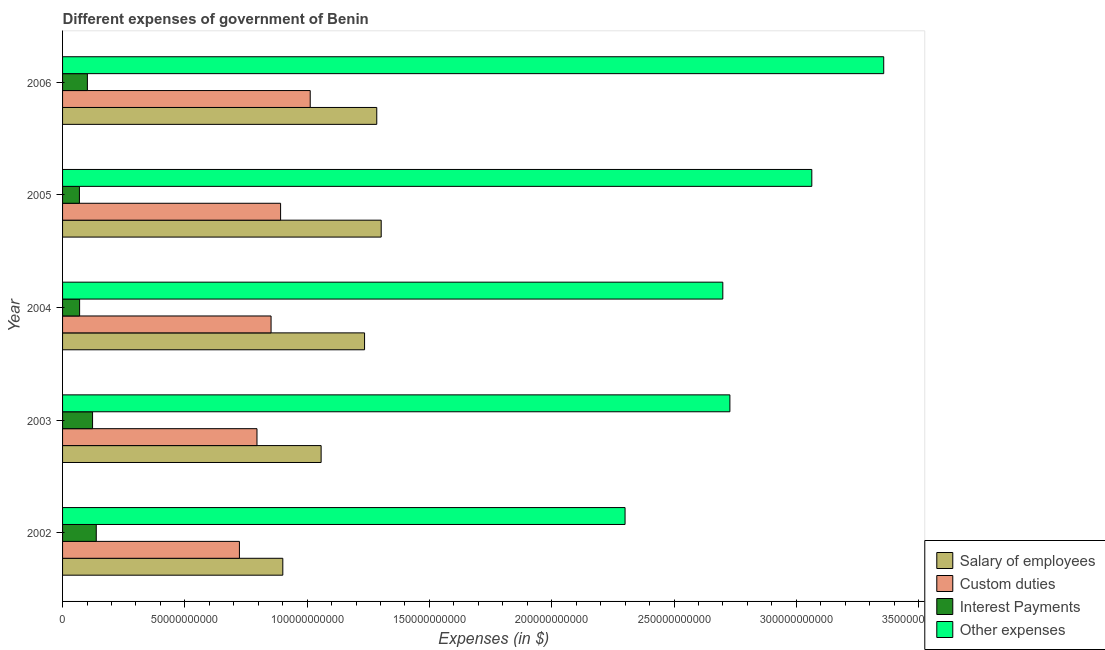How many groups of bars are there?
Offer a very short reply. 5. How many bars are there on the 5th tick from the top?
Your answer should be compact. 4. What is the label of the 4th group of bars from the top?
Give a very brief answer. 2003. What is the amount spent on other expenses in 2002?
Your response must be concise. 2.30e+11. Across all years, what is the maximum amount spent on custom duties?
Your response must be concise. 1.01e+11. Across all years, what is the minimum amount spent on interest payments?
Your answer should be very brief. 6.89e+09. In which year was the amount spent on salary of employees maximum?
Keep it short and to the point. 2005. In which year was the amount spent on custom duties minimum?
Keep it short and to the point. 2002. What is the total amount spent on salary of employees in the graph?
Ensure brevity in your answer.  5.78e+11. What is the difference between the amount spent on other expenses in 2002 and that in 2006?
Your answer should be compact. -1.06e+11. What is the difference between the amount spent on custom duties in 2006 and the amount spent on other expenses in 2002?
Your answer should be very brief. -1.29e+11. What is the average amount spent on salary of employees per year?
Your answer should be very brief. 1.16e+11. In the year 2004, what is the difference between the amount spent on custom duties and amount spent on interest payments?
Provide a short and direct response. 7.83e+1. Is the amount spent on interest payments in 2003 less than that in 2006?
Offer a terse response. No. Is the difference between the amount spent on interest payments in 2002 and 2004 greater than the difference between the amount spent on other expenses in 2002 and 2004?
Provide a short and direct response. Yes. What is the difference between the highest and the second highest amount spent on interest payments?
Make the answer very short. 1.51e+09. What is the difference between the highest and the lowest amount spent on salary of employees?
Your response must be concise. 4.02e+1. In how many years, is the amount spent on interest payments greater than the average amount spent on interest payments taken over all years?
Provide a succinct answer. 3. Is it the case that in every year, the sum of the amount spent on other expenses and amount spent on salary of employees is greater than the sum of amount spent on interest payments and amount spent on custom duties?
Give a very brief answer. No. What does the 1st bar from the top in 2003 represents?
Offer a very short reply. Other expenses. What does the 2nd bar from the bottom in 2006 represents?
Keep it short and to the point. Custom duties. Is it the case that in every year, the sum of the amount spent on salary of employees and amount spent on custom duties is greater than the amount spent on interest payments?
Your answer should be very brief. Yes. How many bars are there?
Your answer should be compact. 20. How many years are there in the graph?
Ensure brevity in your answer.  5. Are the values on the major ticks of X-axis written in scientific E-notation?
Your answer should be compact. No. Does the graph contain any zero values?
Make the answer very short. No. Does the graph contain grids?
Provide a short and direct response. No. What is the title of the graph?
Make the answer very short. Different expenses of government of Benin. Does "Luxembourg" appear as one of the legend labels in the graph?
Your answer should be very brief. No. What is the label or title of the X-axis?
Ensure brevity in your answer.  Expenses (in $). What is the label or title of the Y-axis?
Make the answer very short. Year. What is the Expenses (in $) in Salary of employees in 2002?
Your response must be concise. 9.00e+1. What is the Expenses (in $) in Custom duties in 2002?
Make the answer very short. 7.23e+1. What is the Expenses (in $) in Interest Payments in 2002?
Your answer should be compact. 1.38e+1. What is the Expenses (in $) in Other expenses in 2002?
Provide a succinct answer. 2.30e+11. What is the Expenses (in $) in Salary of employees in 2003?
Provide a succinct answer. 1.06e+11. What is the Expenses (in $) in Custom duties in 2003?
Your answer should be compact. 7.95e+1. What is the Expenses (in $) of Interest Payments in 2003?
Ensure brevity in your answer.  1.23e+1. What is the Expenses (in $) in Other expenses in 2003?
Make the answer very short. 2.73e+11. What is the Expenses (in $) in Salary of employees in 2004?
Offer a very short reply. 1.23e+11. What is the Expenses (in $) of Custom duties in 2004?
Keep it short and to the point. 8.52e+1. What is the Expenses (in $) in Interest Payments in 2004?
Provide a succinct answer. 6.97e+09. What is the Expenses (in $) in Other expenses in 2004?
Give a very brief answer. 2.70e+11. What is the Expenses (in $) of Salary of employees in 2005?
Your answer should be compact. 1.30e+11. What is the Expenses (in $) in Custom duties in 2005?
Make the answer very short. 8.91e+1. What is the Expenses (in $) of Interest Payments in 2005?
Offer a terse response. 6.89e+09. What is the Expenses (in $) of Other expenses in 2005?
Your answer should be very brief. 3.06e+11. What is the Expenses (in $) of Salary of employees in 2006?
Provide a short and direct response. 1.28e+11. What is the Expenses (in $) of Custom duties in 2006?
Offer a terse response. 1.01e+11. What is the Expenses (in $) in Interest Payments in 2006?
Offer a very short reply. 1.01e+1. What is the Expenses (in $) in Other expenses in 2006?
Your answer should be compact. 3.36e+11. Across all years, what is the maximum Expenses (in $) of Salary of employees?
Provide a succinct answer. 1.30e+11. Across all years, what is the maximum Expenses (in $) of Custom duties?
Offer a terse response. 1.01e+11. Across all years, what is the maximum Expenses (in $) in Interest Payments?
Make the answer very short. 1.38e+1. Across all years, what is the maximum Expenses (in $) of Other expenses?
Offer a very short reply. 3.36e+11. Across all years, what is the minimum Expenses (in $) of Salary of employees?
Offer a very short reply. 9.00e+1. Across all years, what is the minimum Expenses (in $) of Custom duties?
Give a very brief answer. 7.23e+1. Across all years, what is the minimum Expenses (in $) in Interest Payments?
Your answer should be very brief. 6.89e+09. Across all years, what is the minimum Expenses (in $) of Other expenses?
Provide a short and direct response. 2.30e+11. What is the total Expenses (in $) in Salary of employees in the graph?
Offer a very short reply. 5.78e+11. What is the total Expenses (in $) in Custom duties in the graph?
Make the answer very short. 4.27e+11. What is the total Expenses (in $) of Interest Payments in the graph?
Provide a short and direct response. 5.01e+1. What is the total Expenses (in $) of Other expenses in the graph?
Make the answer very short. 1.41e+12. What is the difference between the Expenses (in $) in Salary of employees in 2002 and that in 2003?
Make the answer very short. -1.57e+1. What is the difference between the Expenses (in $) of Custom duties in 2002 and that in 2003?
Offer a very short reply. -7.18e+09. What is the difference between the Expenses (in $) of Interest Payments in 2002 and that in 2003?
Provide a short and direct response. 1.51e+09. What is the difference between the Expenses (in $) in Other expenses in 2002 and that in 2003?
Offer a very short reply. -4.29e+1. What is the difference between the Expenses (in $) of Salary of employees in 2002 and that in 2004?
Offer a very short reply. -3.34e+1. What is the difference between the Expenses (in $) in Custom duties in 2002 and that in 2004?
Provide a succinct answer. -1.29e+1. What is the difference between the Expenses (in $) of Interest Payments in 2002 and that in 2004?
Offer a very short reply. 6.81e+09. What is the difference between the Expenses (in $) of Other expenses in 2002 and that in 2004?
Offer a very short reply. -4.00e+1. What is the difference between the Expenses (in $) of Salary of employees in 2002 and that in 2005?
Ensure brevity in your answer.  -4.02e+1. What is the difference between the Expenses (in $) of Custom duties in 2002 and that in 2005?
Give a very brief answer. -1.68e+1. What is the difference between the Expenses (in $) in Interest Payments in 2002 and that in 2005?
Offer a terse response. 6.89e+09. What is the difference between the Expenses (in $) in Other expenses in 2002 and that in 2005?
Provide a short and direct response. -7.64e+1. What is the difference between the Expenses (in $) in Salary of employees in 2002 and that in 2006?
Keep it short and to the point. -3.84e+1. What is the difference between the Expenses (in $) in Custom duties in 2002 and that in 2006?
Ensure brevity in your answer.  -2.89e+1. What is the difference between the Expenses (in $) of Interest Payments in 2002 and that in 2006?
Keep it short and to the point. 3.63e+09. What is the difference between the Expenses (in $) in Other expenses in 2002 and that in 2006?
Provide a succinct answer. -1.06e+11. What is the difference between the Expenses (in $) of Salary of employees in 2003 and that in 2004?
Your answer should be compact. -1.78e+1. What is the difference between the Expenses (in $) in Custom duties in 2003 and that in 2004?
Ensure brevity in your answer.  -5.75e+09. What is the difference between the Expenses (in $) in Interest Payments in 2003 and that in 2004?
Make the answer very short. 5.30e+09. What is the difference between the Expenses (in $) of Other expenses in 2003 and that in 2004?
Your answer should be compact. 2.89e+09. What is the difference between the Expenses (in $) of Salary of employees in 2003 and that in 2005?
Provide a succinct answer. -2.46e+1. What is the difference between the Expenses (in $) in Custom duties in 2003 and that in 2005?
Offer a terse response. -9.65e+09. What is the difference between the Expenses (in $) of Interest Payments in 2003 and that in 2005?
Keep it short and to the point. 5.38e+09. What is the difference between the Expenses (in $) in Other expenses in 2003 and that in 2005?
Provide a short and direct response. -3.35e+1. What is the difference between the Expenses (in $) in Salary of employees in 2003 and that in 2006?
Your response must be concise. -2.27e+1. What is the difference between the Expenses (in $) of Custom duties in 2003 and that in 2006?
Offer a terse response. -2.18e+1. What is the difference between the Expenses (in $) in Interest Payments in 2003 and that in 2006?
Offer a terse response. 2.12e+09. What is the difference between the Expenses (in $) in Other expenses in 2003 and that in 2006?
Your answer should be compact. -6.29e+1. What is the difference between the Expenses (in $) in Salary of employees in 2004 and that in 2005?
Your answer should be compact. -6.80e+09. What is the difference between the Expenses (in $) in Custom duties in 2004 and that in 2005?
Keep it short and to the point. -3.90e+09. What is the difference between the Expenses (in $) in Interest Payments in 2004 and that in 2005?
Provide a short and direct response. 8.00e+07. What is the difference between the Expenses (in $) of Other expenses in 2004 and that in 2005?
Your answer should be very brief. -3.64e+1. What is the difference between the Expenses (in $) in Salary of employees in 2004 and that in 2006?
Make the answer very short. -4.99e+09. What is the difference between the Expenses (in $) in Custom duties in 2004 and that in 2006?
Your response must be concise. -1.60e+1. What is the difference between the Expenses (in $) in Interest Payments in 2004 and that in 2006?
Offer a very short reply. -3.18e+09. What is the difference between the Expenses (in $) in Other expenses in 2004 and that in 2006?
Your response must be concise. -6.58e+1. What is the difference between the Expenses (in $) of Salary of employees in 2005 and that in 2006?
Provide a succinct answer. 1.81e+09. What is the difference between the Expenses (in $) in Custom duties in 2005 and that in 2006?
Ensure brevity in your answer.  -1.21e+1. What is the difference between the Expenses (in $) in Interest Payments in 2005 and that in 2006?
Offer a very short reply. -3.26e+09. What is the difference between the Expenses (in $) of Other expenses in 2005 and that in 2006?
Offer a terse response. -2.94e+1. What is the difference between the Expenses (in $) in Salary of employees in 2002 and the Expenses (in $) in Custom duties in 2003?
Offer a terse response. 1.06e+1. What is the difference between the Expenses (in $) of Salary of employees in 2002 and the Expenses (in $) of Interest Payments in 2003?
Give a very brief answer. 7.78e+1. What is the difference between the Expenses (in $) in Salary of employees in 2002 and the Expenses (in $) in Other expenses in 2003?
Your answer should be very brief. -1.83e+11. What is the difference between the Expenses (in $) of Custom duties in 2002 and the Expenses (in $) of Interest Payments in 2003?
Offer a terse response. 6.00e+1. What is the difference between the Expenses (in $) of Custom duties in 2002 and the Expenses (in $) of Other expenses in 2003?
Give a very brief answer. -2.01e+11. What is the difference between the Expenses (in $) of Interest Payments in 2002 and the Expenses (in $) of Other expenses in 2003?
Give a very brief answer. -2.59e+11. What is the difference between the Expenses (in $) in Salary of employees in 2002 and the Expenses (in $) in Custom duties in 2004?
Offer a terse response. 4.80e+09. What is the difference between the Expenses (in $) in Salary of employees in 2002 and the Expenses (in $) in Interest Payments in 2004?
Keep it short and to the point. 8.31e+1. What is the difference between the Expenses (in $) in Salary of employees in 2002 and the Expenses (in $) in Other expenses in 2004?
Keep it short and to the point. -1.80e+11. What is the difference between the Expenses (in $) of Custom duties in 2002 and the Expenses (in $) of Interest Payments in 2004?
Give a very brief answer. 6.53e+1. What is the difference between the Expenses (in $) of Custom duties in 2002 and the Expenses (in $) of Other expenses in 2004?
Provide a succinct answer. -1.98e+11. What is the difference between the Expenses (in $) of Interest Payments in 2002 and the Expenses (in $) of Other expenses in 2004?
Provide a succinct answer. -2.56e+11. What is the difference between the Expenses (in $) in Salary of employees in 2002 and the Expenses (in $) in Custom duties in 2005?
Provide a short and direct response. 9.05e+08. What is the difference between the Expenses (in $) of Salary of employees in 2002 and the Expenses (in $) of Interest Payments in 2005?
Offer a terse response. 8.32e+1. What is the difference between the Expenses (in $) of Salary of employees in 2002 and the Expenses (in $) of Other expenses in 2005?
Ensure brevity in your answer.  -2.16e+11. What is the difference between the Expenses (in $) in Custom duties in 2002 and the Expenses (in $) in Interest Payments in 2005?
Keep it short and to the point. 6.54e+1. What is the difference between the Expenses (in $) of Custom duties in 2002 and the Expenses (in $) of Other expenses in 2005?
Keep it short and to the point. -2.34e+11. What is the difference between the Expenses (in $) in Interest Payments in 2002 and the Expenses (in $) in Other expenses in 2005?
Make the answer very short. -2.93e+11. What is the difference between the Expenses (in $) in Salary of employees in 2002 and the Expenses (in $) in Custom duties in 2006?
Ensure brevity in your answer.  -1.12e+1. What is the difference between the Expenses (in $) in Salary of employees in 2002 and the Expenses (in $) in Interest Payments in 2006?
Your answer should be very brief. 7.99e+1. What is the difference between the Expenses (in $) of Salary of employees in 2002 and the Expenses (in $) of Other expenses in 2006?
Your response must be concise. -2.46e+11. What is the difference between the Expenses (in $) in Custom duties in 2002 and the Expenses (in $) in Interest Payments in 2006?
Your answer should be very brief. 6.22e+1. What is the difference between the Expenses (in $) in Custom duties in 2002 and the Expenses (in $) in Other expenses in 2006?
Provide a short and direct response. -2.63e+11. What is the difference between the Expenses (in $) in Interest Payments in 2002 and the Expenses (in $) in Other expenses in 2006?
Your answer should be compact. -3.22e+11. What is the difference between the Expenses (in $) in Salary of employees in 2003 and the Expenses (in $) in Custom duties in 2004?
Give a very brief answer. 2.05e+1. What is the difference between the Expenses (in $) of Salary of employees in 2003 and the Expenses (in $) of Interest Payments in 2004?
Offer a terse response. 9.88e+1. What is the difference between the Expenses (in $) in Salary of employees in 2003 and the Expenses (in $) in Other expenses in 2004?
Your answer should be very brief. -1.64e+11. What is the difference between the Expenses (in $) of Custom duties in 2003 and the Expenses (in $) of Interest Payments in 2004?
Your answer should be compact. 7.25e+1. What is the difference between the Expenses (in $) in Custom duties in 2003 and the Expenses (in $) in Other expenses in 2004?
Offer a terse response. -1.90e+11. What is the difference between the Expenses (in $) of Interest Payments in 2003 and the Expenses (in $) of Other expenses in 2004?
Offer a very short reply. -2.58e+11. What is the difference between the Expenses (in $) of Salary of employees in 2003 and the Expenses (in $) of Custom duties in 2005?
Provide a short and direct response. 1.66e+1. What is the difference between the Expenses (in $) in Salary of employees in 2003 and the Expenses (in $) in Interest Payments in 2005?
Make the answer very short. 9.88e+1. What is the difference between the Expenses (in $) of Salary of employees in 2003 and the Expenses (in $) of Other expenses in 2005?
Keep it short and to the point. -2.01e+11. What is the difference between the Expenses (in $) in Custom duties in 2003 and the Expenses (in $) in Interest Payments in 2005?
Ensure brevity in your answer.  7.26e+1. What is the difference between the Expenses (in $) of Custom duties in 2003 and the Expenses (in $) of Other expenses in 2005?
Offer a terse response. -2.27e+11. What is the difference between the Expenses (in $) in Interest Payments in 2003 and the Expenses (in $) in Other expenses in 2005?
Your response must be concise. -2.94e+11. What is the difference between the Expenses (in $) of Salary of employees in 2003 and the Expenses (in $) of Custom duties in 2006?
Your response must be concise. 4.46e+09. What is the difference between the Expenses (in $) in Salary of employees in 2003 and the Expenses (in $) in Interest Payments in 2006?
Your response must be concise. 9.56e+1. What is the difference between the Expenses (in $) of Salary of employees in 2003 and the Expenses (in $) of Other expenses in 2006?
Offer a terse response. -2.30e+11. What is the difference between the Expenses (in $) of Custom duties in 2003 and the Expenses (in $) of Interest Payments in 2006?
Give a very brief answer. 6.93e+1. What is the difference between the Expenses (in $) in Custom duties in 2003 and the Expenses (in $) in Other expenses in 2006?
Make the answer very short. -2.56e+11. What is the difference between the Expenses (in $) of Interest Payments in 2003 and the Expenses (in $) of Other expenses in 2006?
Provide a short and direct response. -3.23e+11. What is the difference between the Expenses (in $) of Salary of employees in 2004 and the Expenses (in $) of Custom duties in 2005?
Offer a very short reply. 3.43e+1. What is the difference between the Expenses (in $) in Salary of employees in 2004 and the Expenses (in $) in Interest Payments in 2005?
Provide a succinct answer. 1.17e+11. What is the difference between the Expenses (in $) in Salary of employees in 2004 and the Expenses (in $) in Other expenses in 2005?
Your answer should be compact. -1.83e+11. What is the difference between the Expenses (in $) of Custom duties in 2004 and the Expenses (in $) of Interest Payments in 2005?
Offer a terse response. 7.84e+1. What is the difference between the Expenses (in $) of Custom duties in 2004 and the Expenses (in $) of Other expenses in 2005?
Ensure brevity in your answer.  -2.21e+11. What is the difference between the Expenses (in $) of Interest Payments in 2004 and the Expenses (in $) of Other expenses in 2005?
Your answer should be compact. -2.99e+11. What is the difference between the Expenses (in $) in Salary of employees in 2004 and the Expenses (in $) in Custom duties in 2006?
Your answer should be compact. 2.22e+1. What is the difference between the Expenses (in $) of Salary of employees in 2004 and the Expenses (in $) of Interest Payments in 2006?
Your answer should be compact. 1.13e+11. What is the difference between the Expenses (in $) in Salary of employees in 2004 and the Expenses (in $) in Other expenses in 2006?
Keep it short and to the point. -2.12e+11. What is the difference between the Expenses (in $) in Custom duties in 2004 and the Expenses (in $) in Interest Payments in 2006?
Your answer should be very brief. 7.51e+1. What is the difference between the Expenses (in $) of Custom duties in 2004 and the Expenses (in $) of Other expenses in 2006?
Ensure brevity in your answer.  -2.50e+11. What is the difference between the Expenses (in $) in Interest Payments in 2004 and the Expenses (in $) in Other expenses in 2006?
Keep it short and to the point. -3.29e+11. What is the difference between the Expenses (in $) of Salary of employees in 2005 and the Expenses (in $) of Custom duties in 2006?
Keep it short and to the point. 2.90e+1. What is the difference between the Expenses (in $) in Salary of employees in 2005 and the Expenses (in $) in Interest Payments in 2006?
Keep it short and to the point. 1.20e+11. What is the difference between the Expenses (in $) in Salary of employees in 2005 and the Expenses (in $) in Other expenses in 2006?
Your response must be concise. -2.05e+11. What is the difference between the Expenses (in $) of Custom duties in 2005 and the Expenses (in $) of Interest Payments in 2006?
Offer a terse response. 7.90e+1. What is the difference between the Expenses (in $) of Custom duties in 2005 and the Expenses (in $) of Other expenses in 2006?
Offer a very short reply. -2.47e+11. What is the difference between the Expenses (in $) of Interest Payments in 2005 and the Expenses (in $) of Other expenses in 2006?
Provide a short and direct response. -3.29e+11. What is the average Expenses (in $) of Salary of employees per year?
Your answer should be very brief. 1.16e+11. What is the average Expenses (in $) in Custom duties per year?
Your answer should be very brief. 8.55e+1. What is the average Expenses (in $) in Interest Payments per year?
Ensure brevity in your answer.  1.00e+1. What is the average Expenses (in $) of Other expenses per year?
Keep it short and to the point. 2.83e+11. In the year 2002, what is the difference between the Expenses (in $) of Salary of employees and Expenses (in $) of Custom duties?
Give a very brief answer. 1.77e+1. In the year 2002, what is the difference between the Expenses (in $) of Salary of employees and Expenses (in $) of Interest Payments?
Your response must be concise. 7.63e+1. In the year 2002, what is the difference between the Expenses (in $) in Salary of employees and Expenses (in $) in Other expenses?
Ensure brevity in your answer.  -1.40e+11. In the year 2002, what is the difference between the Expenses (in $) of Custom duties and Expenses (in $) of Interest Payments?
Provide a short and direct response. 5.85e+1. In the year 2002, what is the difference between the Expenses (in $) in Custom duties and Expenses (in $) in Other expenses?
Your answer should be compact. -1.58e+11. In the year 2002, what is the difference between the Expenses (in $) of Interest Payments and Expenses (in $) of Other expenses?
Your response must be concise. -2.16e+11. In the year 2003, what is the difference between the Expenses (in $) in Salary of employees and Expenses (in $) in Custom duties?
Ensure brevity in your answer.  2.62e+1. In the year 2003, what is the difference between the Expenses (in $) in Salary of employees and Expenses (in $) in Interest Payments?
Offer a terse response. 9.35e+1. In the year 2003, what is the difference between the Expenses (in $) in Salary of employees and Expenses (in $) in Other expenses?
Make the answer very short. -1.67e+11. In the year 2003, what is the difference between the Expenses (in $) in Custom duties and Expenses (in $) in Interest Payments?
Offer a very short reply. 6.72e+1. In the year 2003, what is the difference between the Expenses (in $) of Custom duties and Expenses (in $) of Other expenses?
Offer a terse response. -1.93e+11. In the year 2003, what is the difference between the Expenses (in $) of Interest Payments and Expenses (in $) of Other expenses?
Your response must be concise. -2.61e+11. In the year 2004, what is the difference between the Expenses (in $) of Salary of employees and Expenses (in $) of Custom duties?
Provide a short and direct response. 3.82e+1. In the year 2004, what is the difference between the Expenses (in $) of Salary of employees and Expenses (in $) of Interest Payments?
Your response must be concise. 1.17e+11. In the year 2004, what is the difference between the Expenses (in $) in Salary of employees and Expenses (in $) in Other expenses?
Offer a terse response. -1.46e+11. In the year 2004, what is the difference between the Expenses (in $) of Custom duties and Expenses (in $) of Interest Payments?
Your response must be concise. 7.83e+1. In the year 2004, what is the difference between the Expenses (in $) in Custom duties and Expenses (in $) in Other expenses?
Your answer should be compact. -1.85e+11. In the year 2004, what is the difference between the Expenses (in $) in Interest Payments and Expenses (in $) in Other expenses?
Offer a very short reply. -2.63e+11. In the year 2005, what is the difference between the Expenses (in $) of Salary of employees and Expenses (in $) of Custom duties?
Offer a very short reply. 4.11e+1. In the year 2005, what is the difference between the Expenses (in $) of Salary of employees and Expenses (in $) of Interest Payments?
Offer a terse response. 1.23e+11. In the year 2005, what is the difference between the Expenses (in $) in Salary of employees and Expenses (in $) in Other expenses?
Give a very brief answer. -1.76e+11. In the year 2005, what is the difference between the Expenses (in $) in Custom duties and Expenses (in $) in Interest Payments?
Make the answer very short. 8.23e+1. In the year 2005, what is the difference between the Expenses (in $) in Custom duties and Expenses (in $) in Other expenses?
Your answer should be very brief. -2.17e+11. In the year 2005, what is the difference between the Expenses (in $) of Interest Payments and Expenses (in $) of Other expenses?
Give a very brief answer. -2.99e+11. In the year 2006, what is the difference between the Expenses (in $) in Salary of employees and Expenses (in $) in Custom duties?
Offer a terse response. 2.72e+1. In the year 2006, what is the difference between the Expenses (in $) of Salary of employees and Expenses (in $) of Interest Payments?
Your answer should be very brief. 1.18e+11. In the year 2006, what is the difference between the Expenses (in $) in Salary of employees and Expenses (in $) in Other expenses?
Offer a terse response. -2.07e+11. In the year 2006, what is the difference between the Expenses (in $) of Custom duties and Expenses (in $) of Interest Payments?
Your answer should be compact. 9.11e+1. In the year 2006, what is the difference between the Expenses (in $) of Custom duties and Expenses (in $) of Other expenses?
Offer a very short reply. -2.34e+11. In the year 2006, what is the difference between the Expenses (in $) in Interest Payments and Expenses (in $) in Other expenses?
Your response must be concise. -3.26e+11. What is the ratio of the Expenses (in $) in Salary of employees in 2002 to that in 2003?
Keep it short and to the point. 0.85. What is the ratio of the Expenses (in $) of Custom duties in 2002 to that in 2003?
Ensure brevity in your answer.  0.91. What is the ratio of the Expenses (in $) of Interest Payments in 2002 to that in 2003?
Your answer should be compact. 1.12. What is the ratio of the Expenses (in $) in Other expenses in 2002 to that in 2003?
Offer a terse response. 0.84. What is the ratio of the Expenses (in $) of Salary of employees in 2002 to that in 2004?
Give a very brief answer. 0.73. What is the ratio of the Expenses (in $) of Custom duties in 2002 to that in 2004?
Give a very brief answer. 0.85. What is the ratio of the Expenses (in $) of Interest Payments in 2002 to that in 2004?
Your answer should be compact. 1.98. What is the ratio of the Expenses (in $) in Other expenses in 2002 to that in 2004?
Give a very brief answer. 0.85. What is the ratio of the Expenses (in $) in Salary of employees in 2002 to that in 2005?
Your answer should be compact. 0.69. What is the ratio of the Expenses (in $) of Custom duties in 2002 to that in 2005?
Your answer should be very brief. 0.81. What is the ratio of the Expenses (in $) of Other expenses in 2002 to that in 2005?
Your response must be concise. 0.75. What is the ratio of the Expenses (in $) of Salary of employees in 2002 to that in 2006?
Offer a terse response. 0.7. What is the ratio of the Expenses (in $) of Custom duties in 2002 to that in 2006?
Provide a succinct answer. 0.71. What is the ratio of the Expenses (in $) in Interest Payments in 2002 to that in 2006?
Provide a short and direct response. 1.36. What is the ratio of the Expenses (in $) in Other expenses in 2002 to that in 2006?
Make the answer very short. 0.69. What is the ratio of the Expenses (in $) in Salary of employees in 2003 to that in 2004?
Your answer should be compact. 0.86. What is the ratio of the Expenses (in $) of Custom duties in 2003 to that in 2004?
Keep it short and to the point. 0.93. What is the ratio of the Expenses (in $) of Interest Payments in 2003 to that in 2004?
Offer a terse response. 1.76. What is the ratio of the Expenses (in $) in Other expenses in 2003 to that in 2004?
Provide a short and direct response. 1.01. What is the ratio of the Expenses (in $) of Salary of employees in 2003 to that in 2005?
Your response must be concise. 0.81. What is the ratio of the Expenses (in $) in Custom duties in 2003 to that in 2005?
Provide a short and direct response. 0.89. What is the ratio of the Expenses (in $) of Interest Payments in 2003 to that in 2005?
Offer a terse response. 1.78. What is the ratio of the Expenses (in $) in Other expenses in 2003 to that in 2005?
Your answer should be compact. 0.89. What is the ratio of the Expenses (in $) in Salary of employees in 2003 to that in 2006?
Make the answer very short. 0.82. What is the ratio of the Expenses (in $) of Custom duties in 2003 to that in 2006?
Your answer should be compact. 0.79. What is the ratio of the Expenses (in $) of Interest Payments in 2003 to that in 2006?
Keep it short and to the point. 1.21. What is the ratio of the Expenses (in $) in Other expenses in 2003 to that in 2006?
Provide a succinct answer. 0.81. What is the ratio of the Expenses (in $) in Salary of employees in 2004 to that in 2005?
Ensure brevity in your answer.  0.95. What is the ratio of the Expenses (in $) of Custom duties in 2004 to that in 2005?
Give a very brief answer. 0.96. What is the ratio of the Expenses (in $) in Interest Payments in 2004 to that in 2005?
Offer a very short reply. 1.01. What is the ratio of the Expenses (in $) of Other expenses in 2004 to that in 2005?
Make the answer very short. 0.88. What is the ratio of the Expenses (in $) of Salary of employees in 2004 to that in 2006?
Provide a succinct answer. 0.96. What is the ratio of the Expenses (in $) of Custom duties in 2004 to that in 2006?
Provide a succinct answer. 0.84. What is the ratio of the Expenses (in $) in Interest Payments in 2004 to that in 2006?
Keep it short and to the point. 0.69. What is the ratio of the Expenses (in $) in Other expenses in 2004 to that in 2006?
Keep it short and to the point. 0.8. What is the ratio of the Expenses (in $) in Salary of employees in 2005 to that in 2006?
Your response must be concise. 1.01. What is the ratio of the Expenses (in $) of Custom duties in 2005 to that in 2006?
Your answer should be very brief. 0.88. What is the ratio of the Expenses (in $) of Interest Payments in 2005 to that in 2006?
Offer a very short reply. 0.68. What is the ratio of the Expenses (in $) of Other expenses in 2005 to that in 2006?
Offer a very short reply. 0.91. What is the difference between the highest and the second highest Expenses (in $) of Salary of employees?
Ensure brevity in your answer.  1.81e+09. What is the difference between the highest and the second highest Expenses (in $) in Custom duties?
Provide a short and direct response. 1.21e+1. What is the difference between the highest and the second highest Expenses (in $) in Interest Payments?
Offer a very short reply. 1.51e+09. What is the difference between the highest and the second highest Expenses (in $) in Other expenses?
Offer a very short reply. 2.94e+1. What is the difference between the highest and the lowest Expenses (in $) in Salary of employees?
Your response must be concise. 4.02e+1. What is the difference between the highest and the lowest Expenses (in $) of Custom duties?
Offer a terse response. 2.89e+1. What is the difference between the highest and the lowest Expenses (in $) of Interest Payments?
Your answer should be very brief. 6.89e+09. What is the difference between the highest and the lowest Expenses (in $) of Other expenses?
Provide a short and direct response. 1.06e+11. 